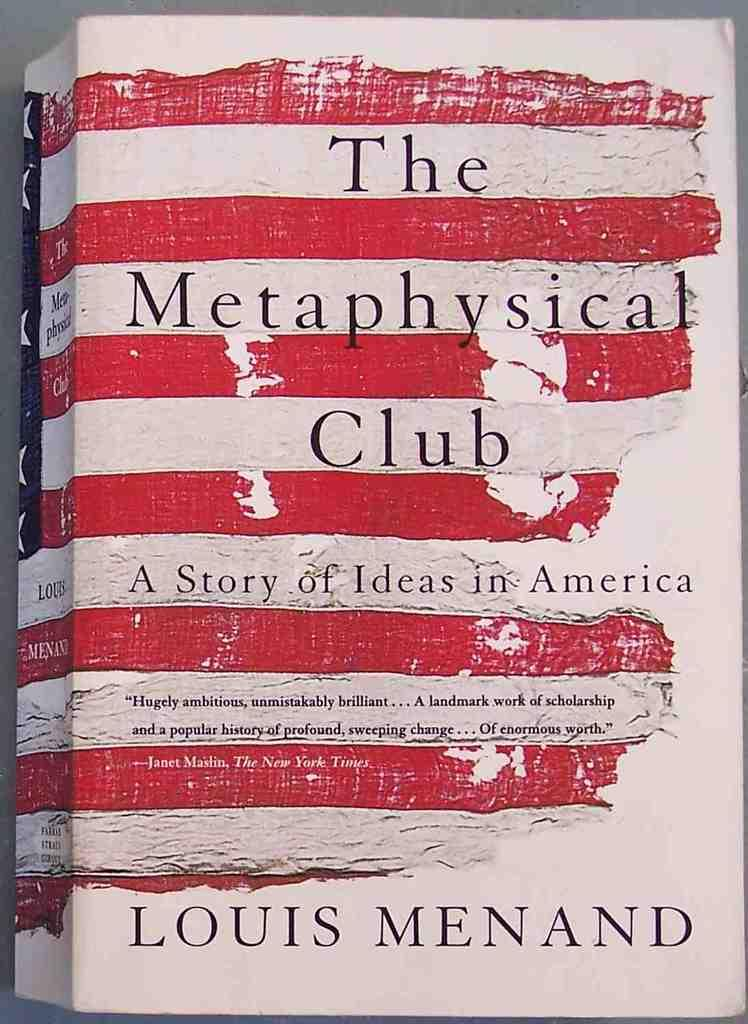<image>
Share a concise interpretation of the image provided. The book called the Metaphysical Club was written by Louis Manand. 